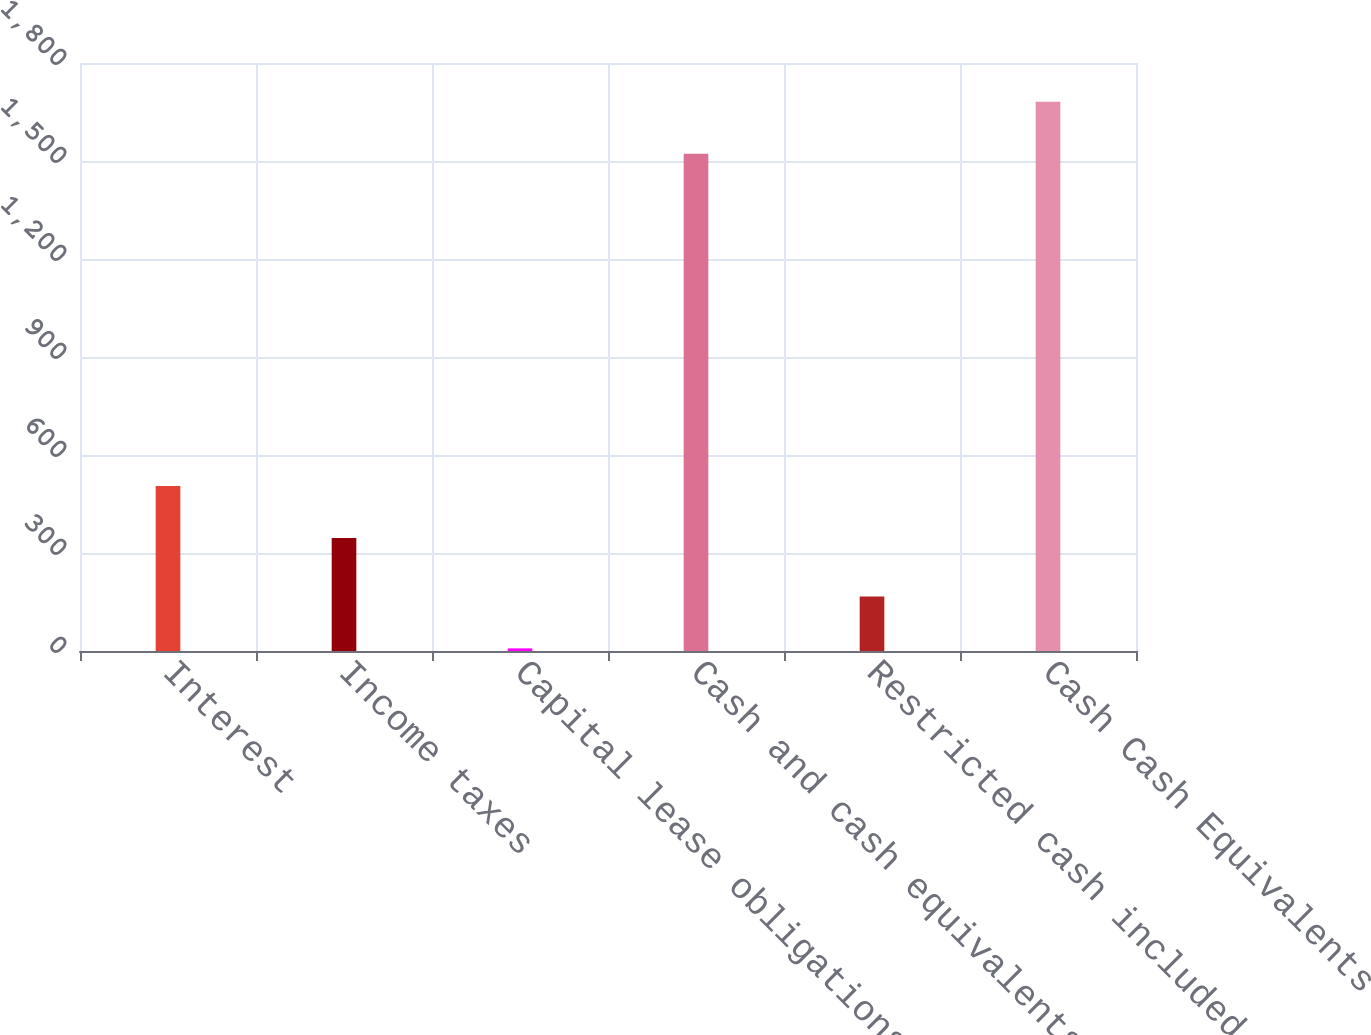Convert chart. <chart><loc_0><loc_0><loc_500><loc_500><bar_chart><fcel>Interest<fcel>Income taxes<fcel>Capital lease obligations<fcel>Cash and cash equivalents as<fcel>Restricted cash included in<fcel>Cash Cash Equivalents and<nl><fcel>505.1<fcel>346<fcel>8<fcel>1522<fcel>167.1<fcel>1681.1<nl></chart> 